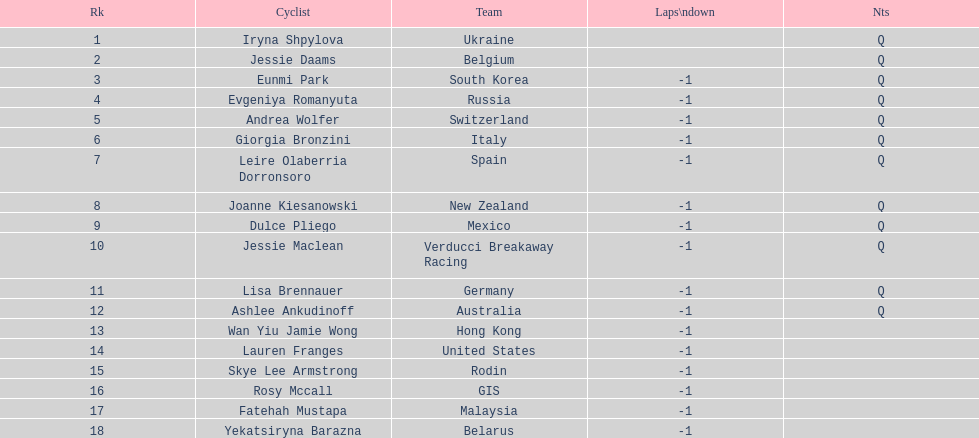How many cyclist are not listed with a country team? 3. 